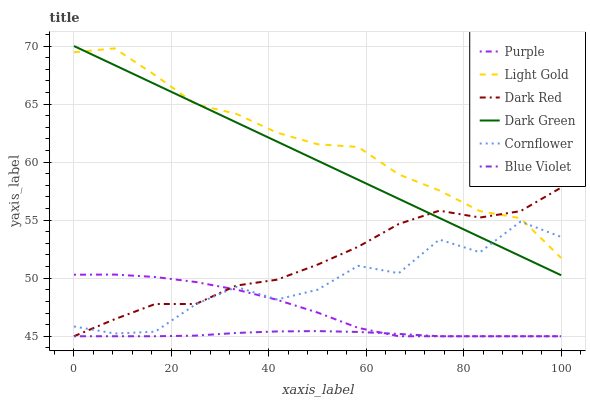Does Purple have the minimum area under the curve?
Answer yes or no. No. Does Purple have the maximum area under the curve?
Answer yes or no. No. Is Purple the smoothest?
Answer yes or no. No. Is Purple the roughest?
Answer yes or no. No. Does Light Gold have the lowest value?
Answer yes or no. No. Does Purple have the highest value?
Answer yes or no. No. Is Purple less than Light Gold?
Answer yes or no. Yes. Is Light Gold greater than Blue Violet?
Answer yes or no. Yes. Does Purple intersect Light Gold?
Answer yes or no. No. 